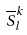Convert formula to latex. <formula><loc_0><loc_0><loc_500><loc_500>\overline { S } _ { l } ^ { k }</formula> 